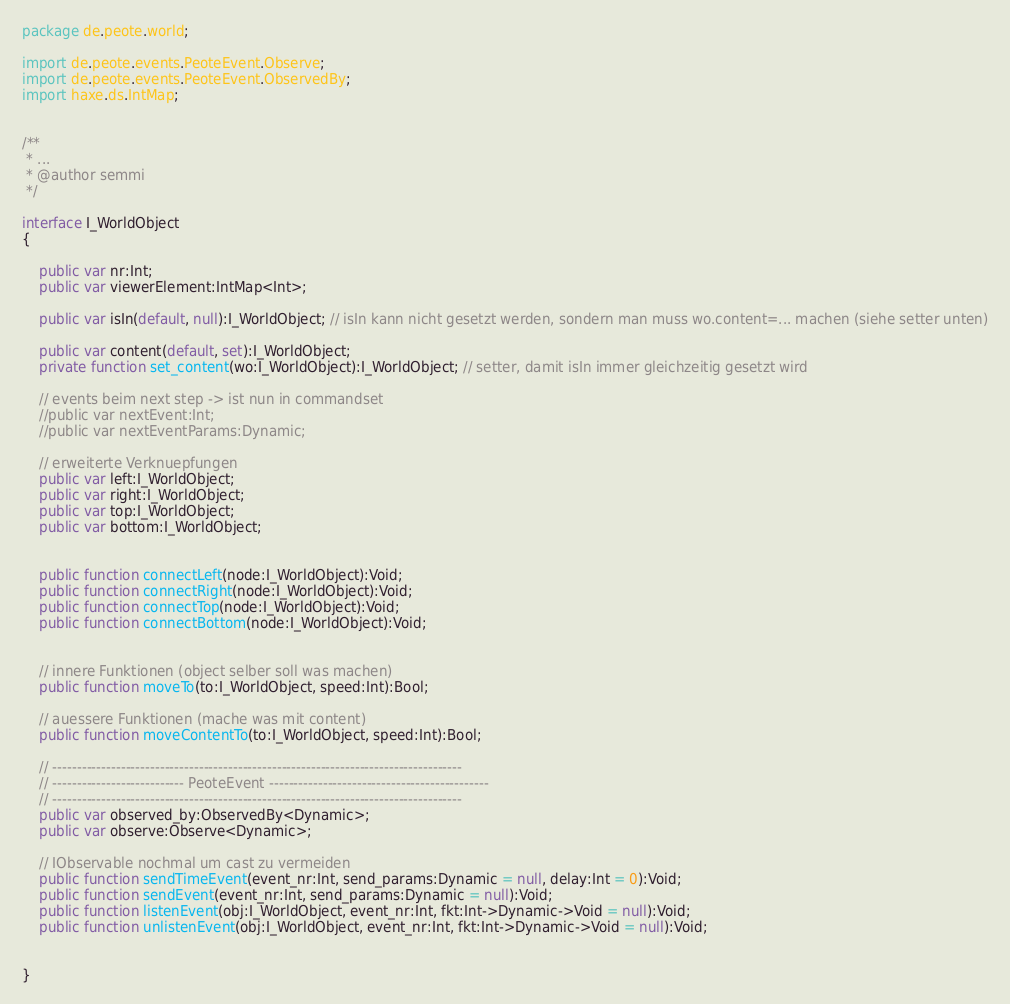Convert code to text. <code><loc_0><loc_0><loc_500><loc_500><_Haxe_>package de.peote.world;

import de.peote.events.PeoteEvent.Observe;
import de.peote.events.PeoteEvent.ObservedBy;
import haxe.ds.IntMap;


/**
 * ...
 * @author semmi
 */

interface I_WorldObject 
{

	public var nr:Int;
	public var viewerElement:IntMap<Int>;
	
	public var isIn(default, null):I_WorldObject; // isIn kann nicht gesetzt werden, sondern man muss wo.content=... machen (siehe setter unten)
	
	public var content(default, set):I_WorldObject;
	private function set_content(wo:I_WorldObject):I_WorldObject; // setter, damit isIn immer gleichzeitig gesetzt wird

	// events beim next step -> ist nun in commandset
	//public var nextEvent:Int;
	//public var nextEventParams:Dynamic;

	// erweiterte Verknuepfungen
	public var left:I_WorldObject;
	public var right:I_WorldObject;
	public var top:I_WorldObject;
	public var bottom:I_WorldObject;

	
	public function connectLeft(node:I_WorldObject):Void;
	public function connectRight(node:I_WorldObject):Void;
	public function connectTop(node:I_WorldObject):Void;
	public function connectBottom(node:I_WorldObject):Void;


	// innere Funktionen (object selber soll was machen)
	public function moveTo(to:I_WorldObject, speed:Int):Bool;
	
	// auessere Funktionen (mache was mit content)
	public function moveContentTo(to:I_WorldObject, speed:Int):Bool;
		
	// ------------------------------------------------------------------------------------
	// --------------------------- PeoteEvent ---------------------------------------------
	// ------------------------------------------------------------------------------------
	public var observed_by:ObservedBy<Dynamic>;
	public var observe:Observe<Dynamic>;
	
	// IObservable nochmal um cast zu vermeiden
	public function sendTimeEvent(event_nr:Int, send_params:Dynamic = null, delay:Int = 0):Void;
	public function sendEvent(event_nr:Int, send_params:Dynamic = null):Void;
	public function listenEvent(obj:I_WorldObject, event_nr:Int, fkt:Int->Dynamic->Void = null):Void;
	public function unlistenEvent(obj:I_WorldObject, event_nr:Int, fkt:Int->Dynamic->Void = null):Void;

	
}</code> 